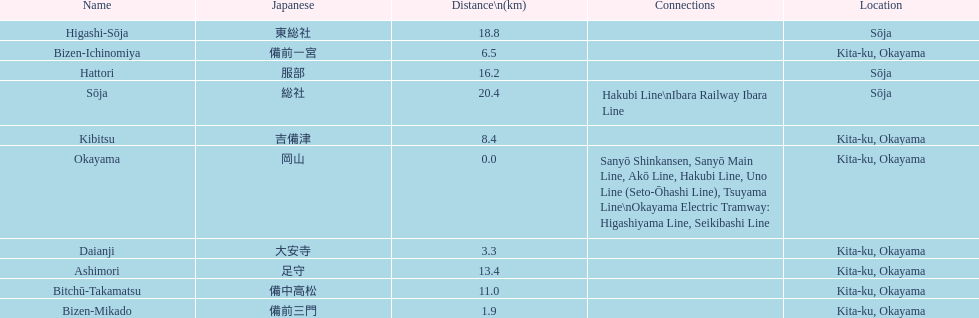How many stations are present in kita-ku, okayama? 7. 